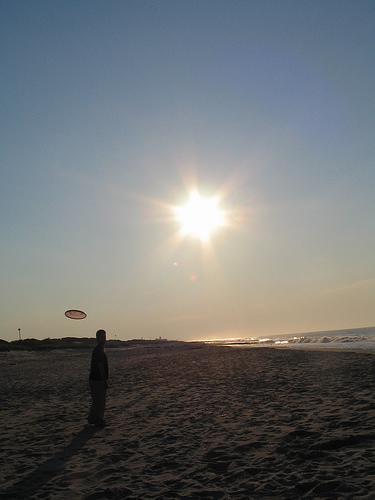How many people are pictured?
Give a very brief answer. 1. 